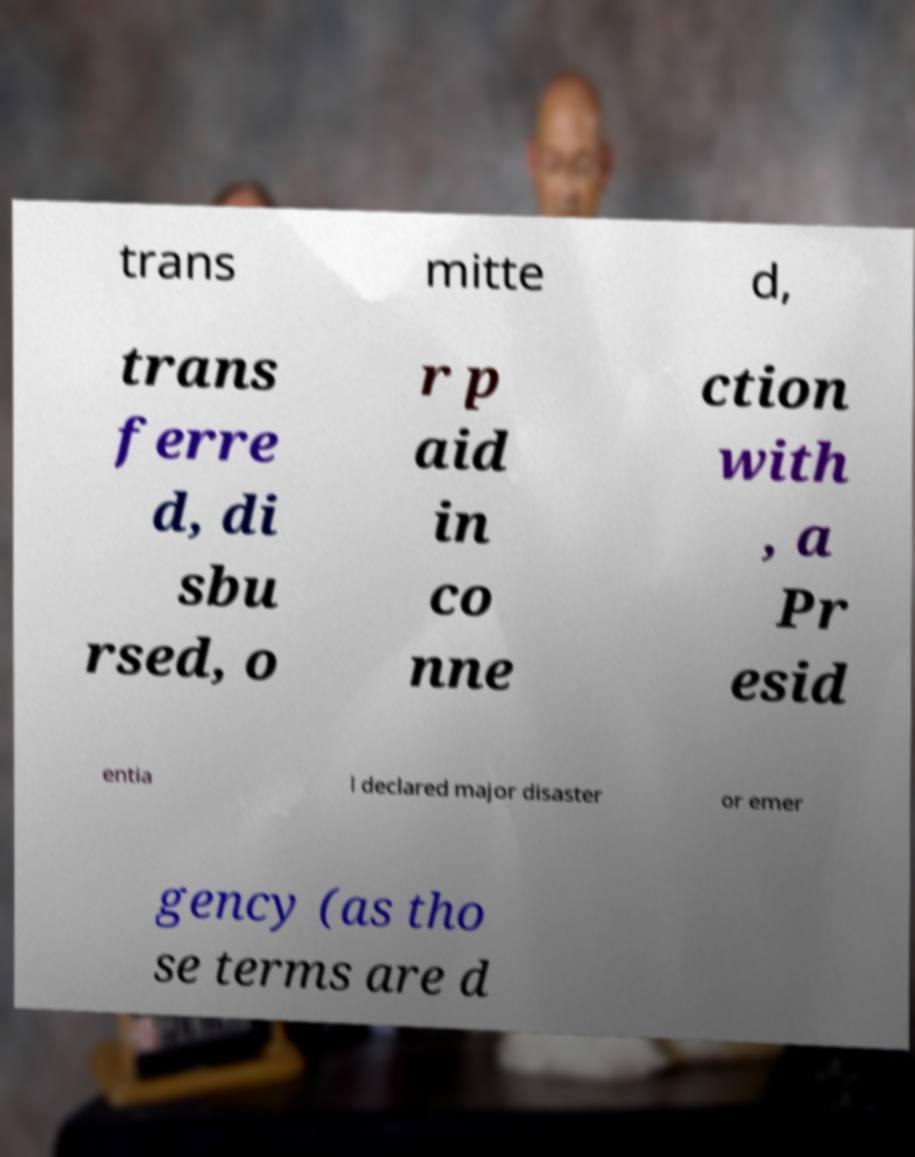Could you assist in decoding the text presented in this image and type it out clearly? trans mitte d, trans ferre d, di sbu rsed, o r p aid in co nne ction with , a Pr esid entia l declared major disaster or emer gency (as tho se terms are d 